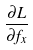Convert formula to latex. <formula><loc_0><loc_0><loc_500><loc_500>\frac { \partial L } { \partial f _ { x } }</formula> 